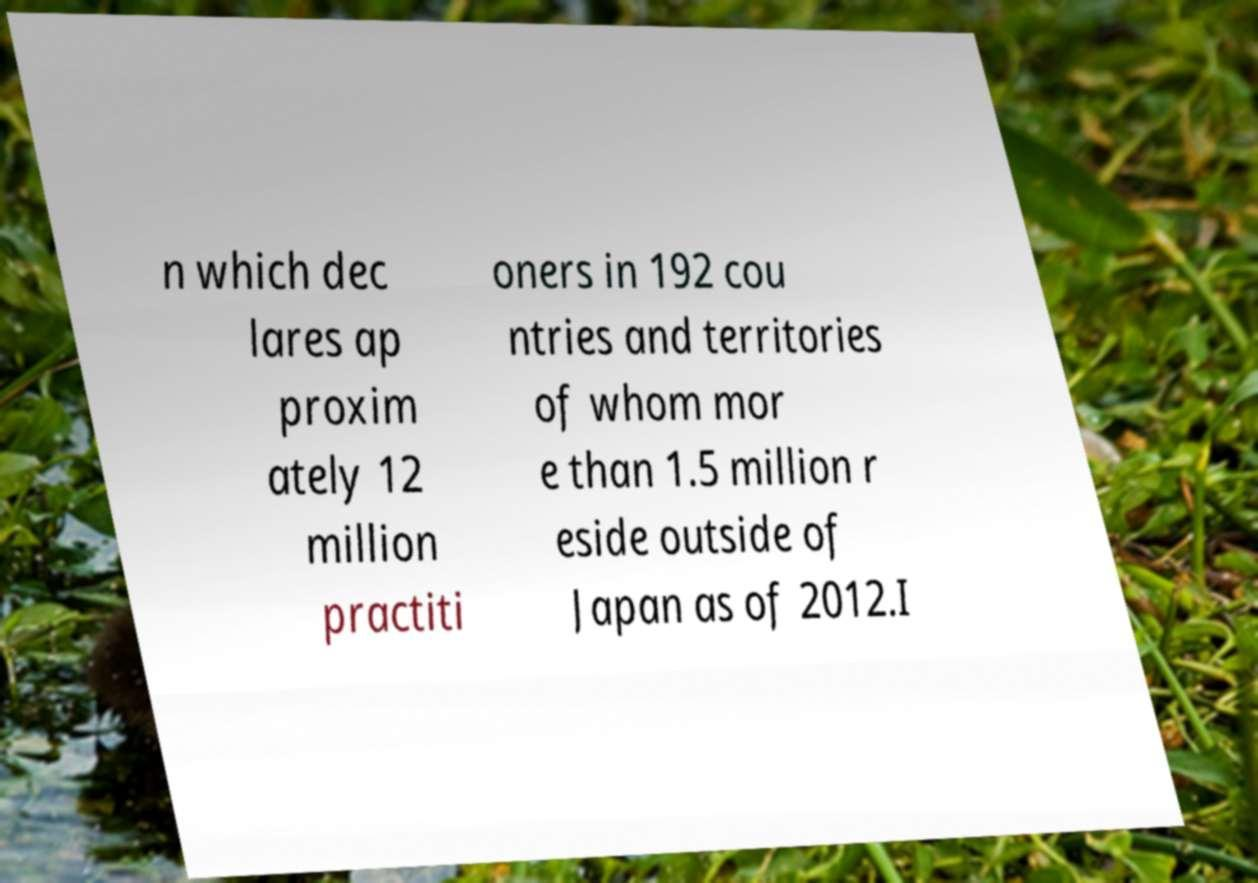There's text embedded in this image that I need extracted. Can you transcribe it verbatim? n which dec lares ap proxim ately 12 million practiti oners in 192 cou ntries and territories of whom mor e than 1.5 million r eside outside of Japan as of 2012.I 